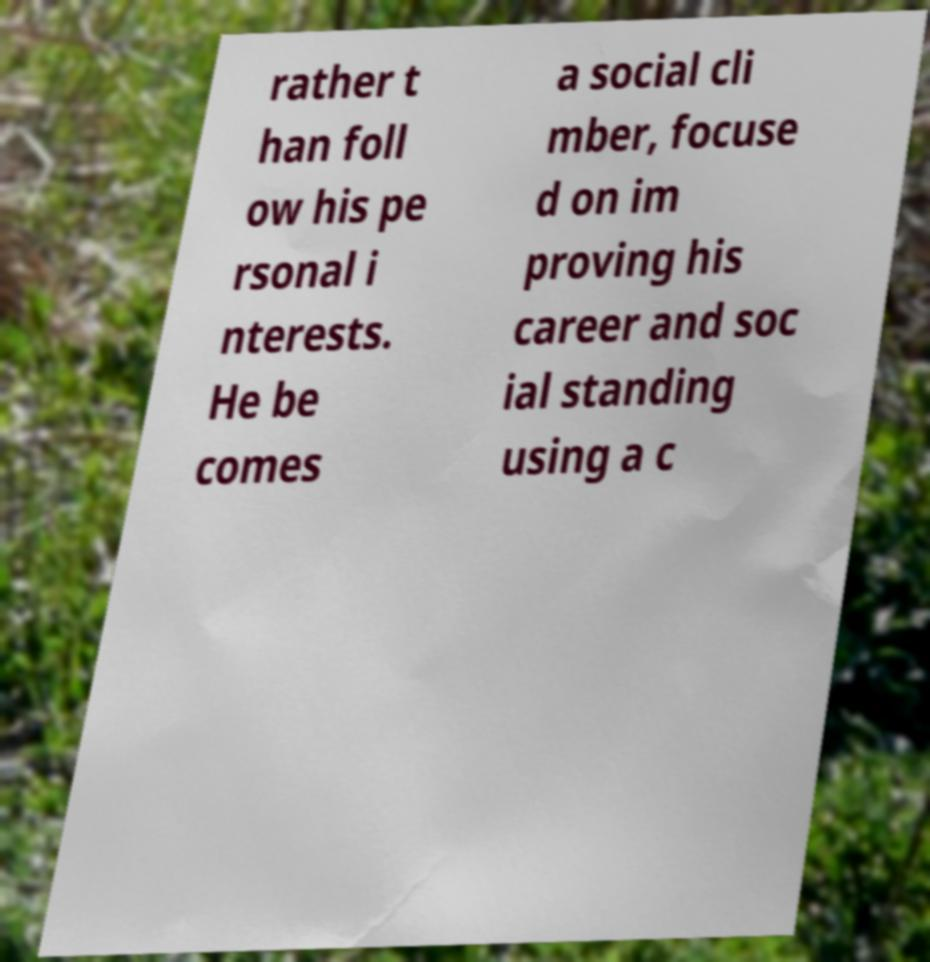Could you assist in decoding the text presented in this image and type it out clearly? rather t han foll ow his pe rsonal i nterests. He be comes a social cli mber, focuse d on im proving his career and soc ial standing using a c 